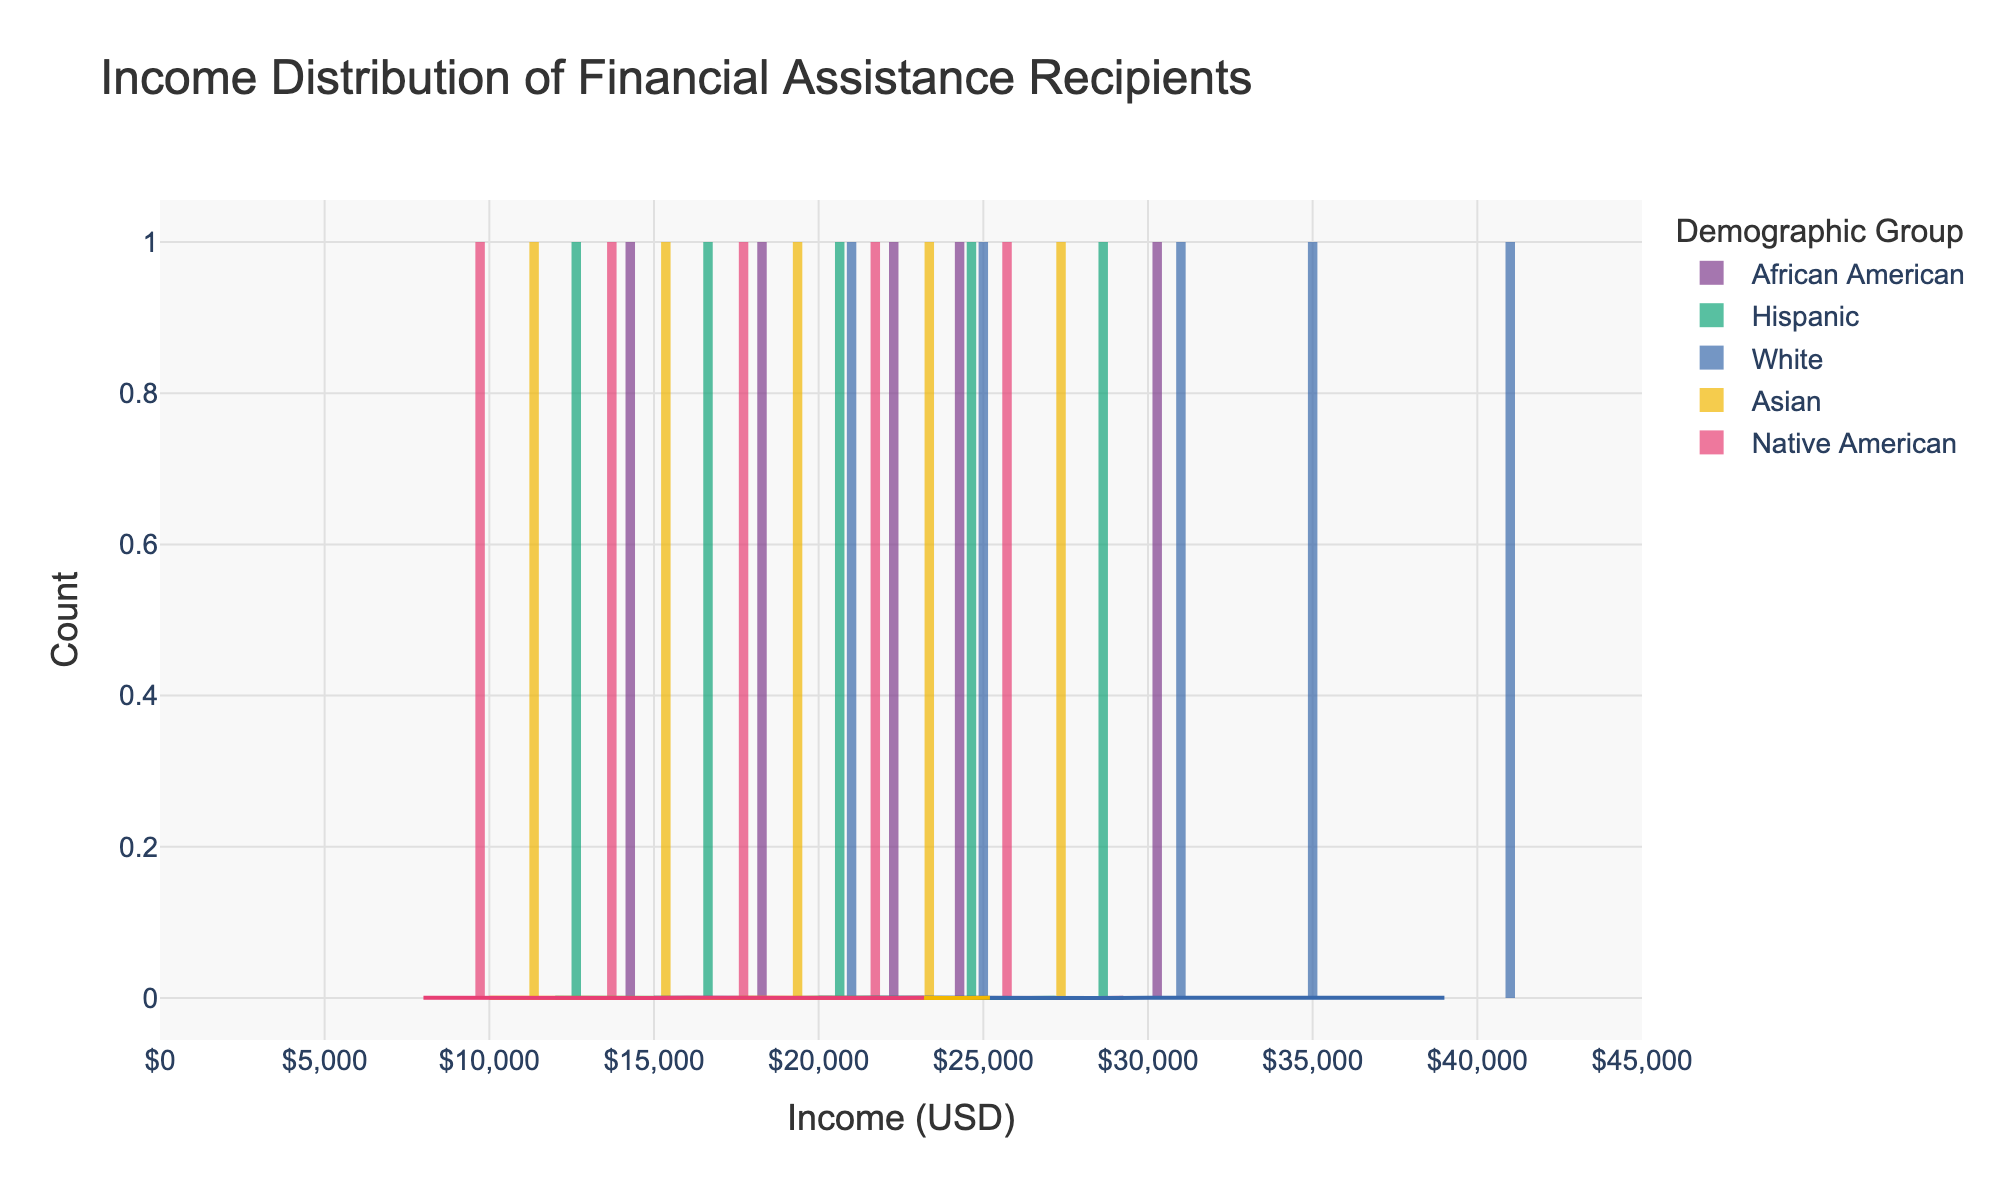What is the title of the figure? The title of the figure is displayed at the top center of the plot area. It reads: "Income Distribution of Financial Assistance Recipients".
Answer: Income Distribution of Financial Assistance Recipients Which demographic group has the highest peak in the KDE curve? By examining the KDE curves, we see that the White demographic group has the highest peak, indicating a higher density of recipients at a certain income level.
Answer: White What is the income range displayed on the x-axis? The x-axis displays the income range, which is from 0 to 45,000 USD.
Answer: 0 to 45,000 USD How does the income distribution of African American recipients compare to that of Native American recipients? Native American recipients have their income distribution concentrated in the lower ranges between 8,000 and 24,000 USD, whereas African American recipients have a wider spread of income distribution ranging from 15,000 to 30,000 USD.
Answer: Native American recipients have a more concentrated lower-income range, while African American recipients have a wider spread Which demographic group has the widest spread in their income distribution? By looking at the histograms and KDEs, the White demographic group's income distribution ranges from 20,000 to 40,000 USD, showing the widest spread of all demographic groups.
Answer: White What can be inferred about the average income for each demographic from their KDE curves? The peaks of the KDE curves give an indication of the central tendency. White recipients show a higher income peak around 30,000 USD, while other groups have peaks at lower income levels. This indicates that the average income for White recipients is likely higher than for other groups.
Answer: White recipients likely have higher average incomes Which demographic group has the least variability in income distribution? By examining the histograms, the Hispanic group's income distribution appears to be clustered around a narrower range between 12,000 and 28,000 USD, indicating less variability compared to other groups.
Answer: Hispanic Does any demographic group have a bimodal distribution in their income? Observing the KDE curves, no demographic group shows a clear bimodal distribution. All groups exhibit unimodal distributions with one prominent peak each.
Answer: No What can you say about the income distribution of Asian recipients based on the plot? The Asian recipients' incomes range from 10,000 to 26,000 USD with a peak at around 18,000 USD, indicating a lower average income compared to other groups.
Answer: Lower average income peaking around 18,000 USD How many bins are used for the histogram in the plot? Each histogram uses 20 bins, as mentioned in the description of the histogram traces.
Answer: 20 